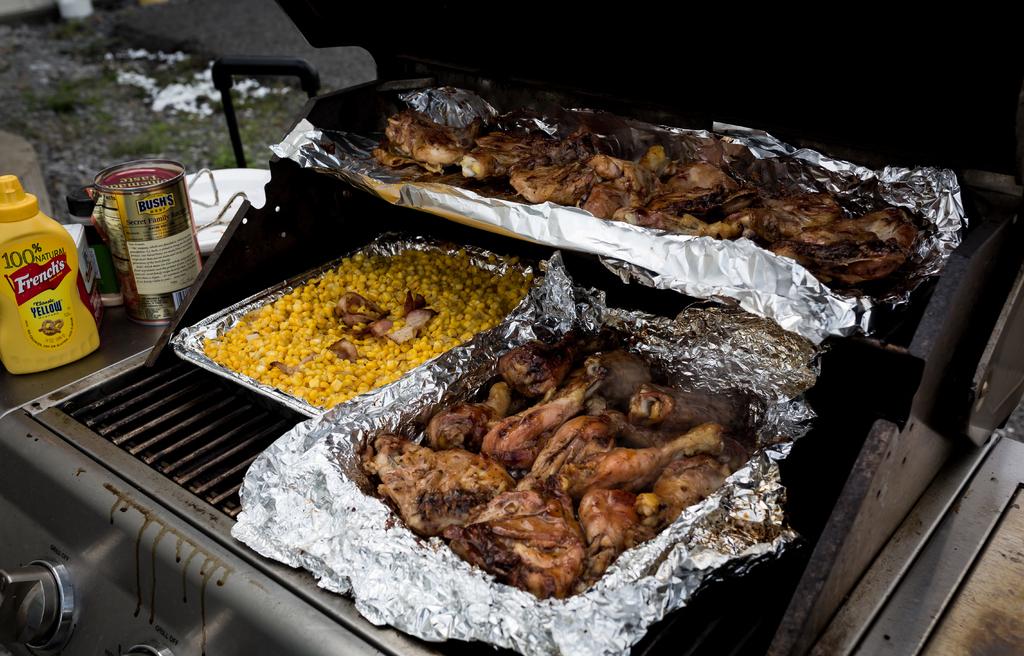What is the brand of mustard on the yellow container?
Ensure brevity in your answer.  French's. What brand is the canned food item?
Your answer should be very brief. Bush's. 